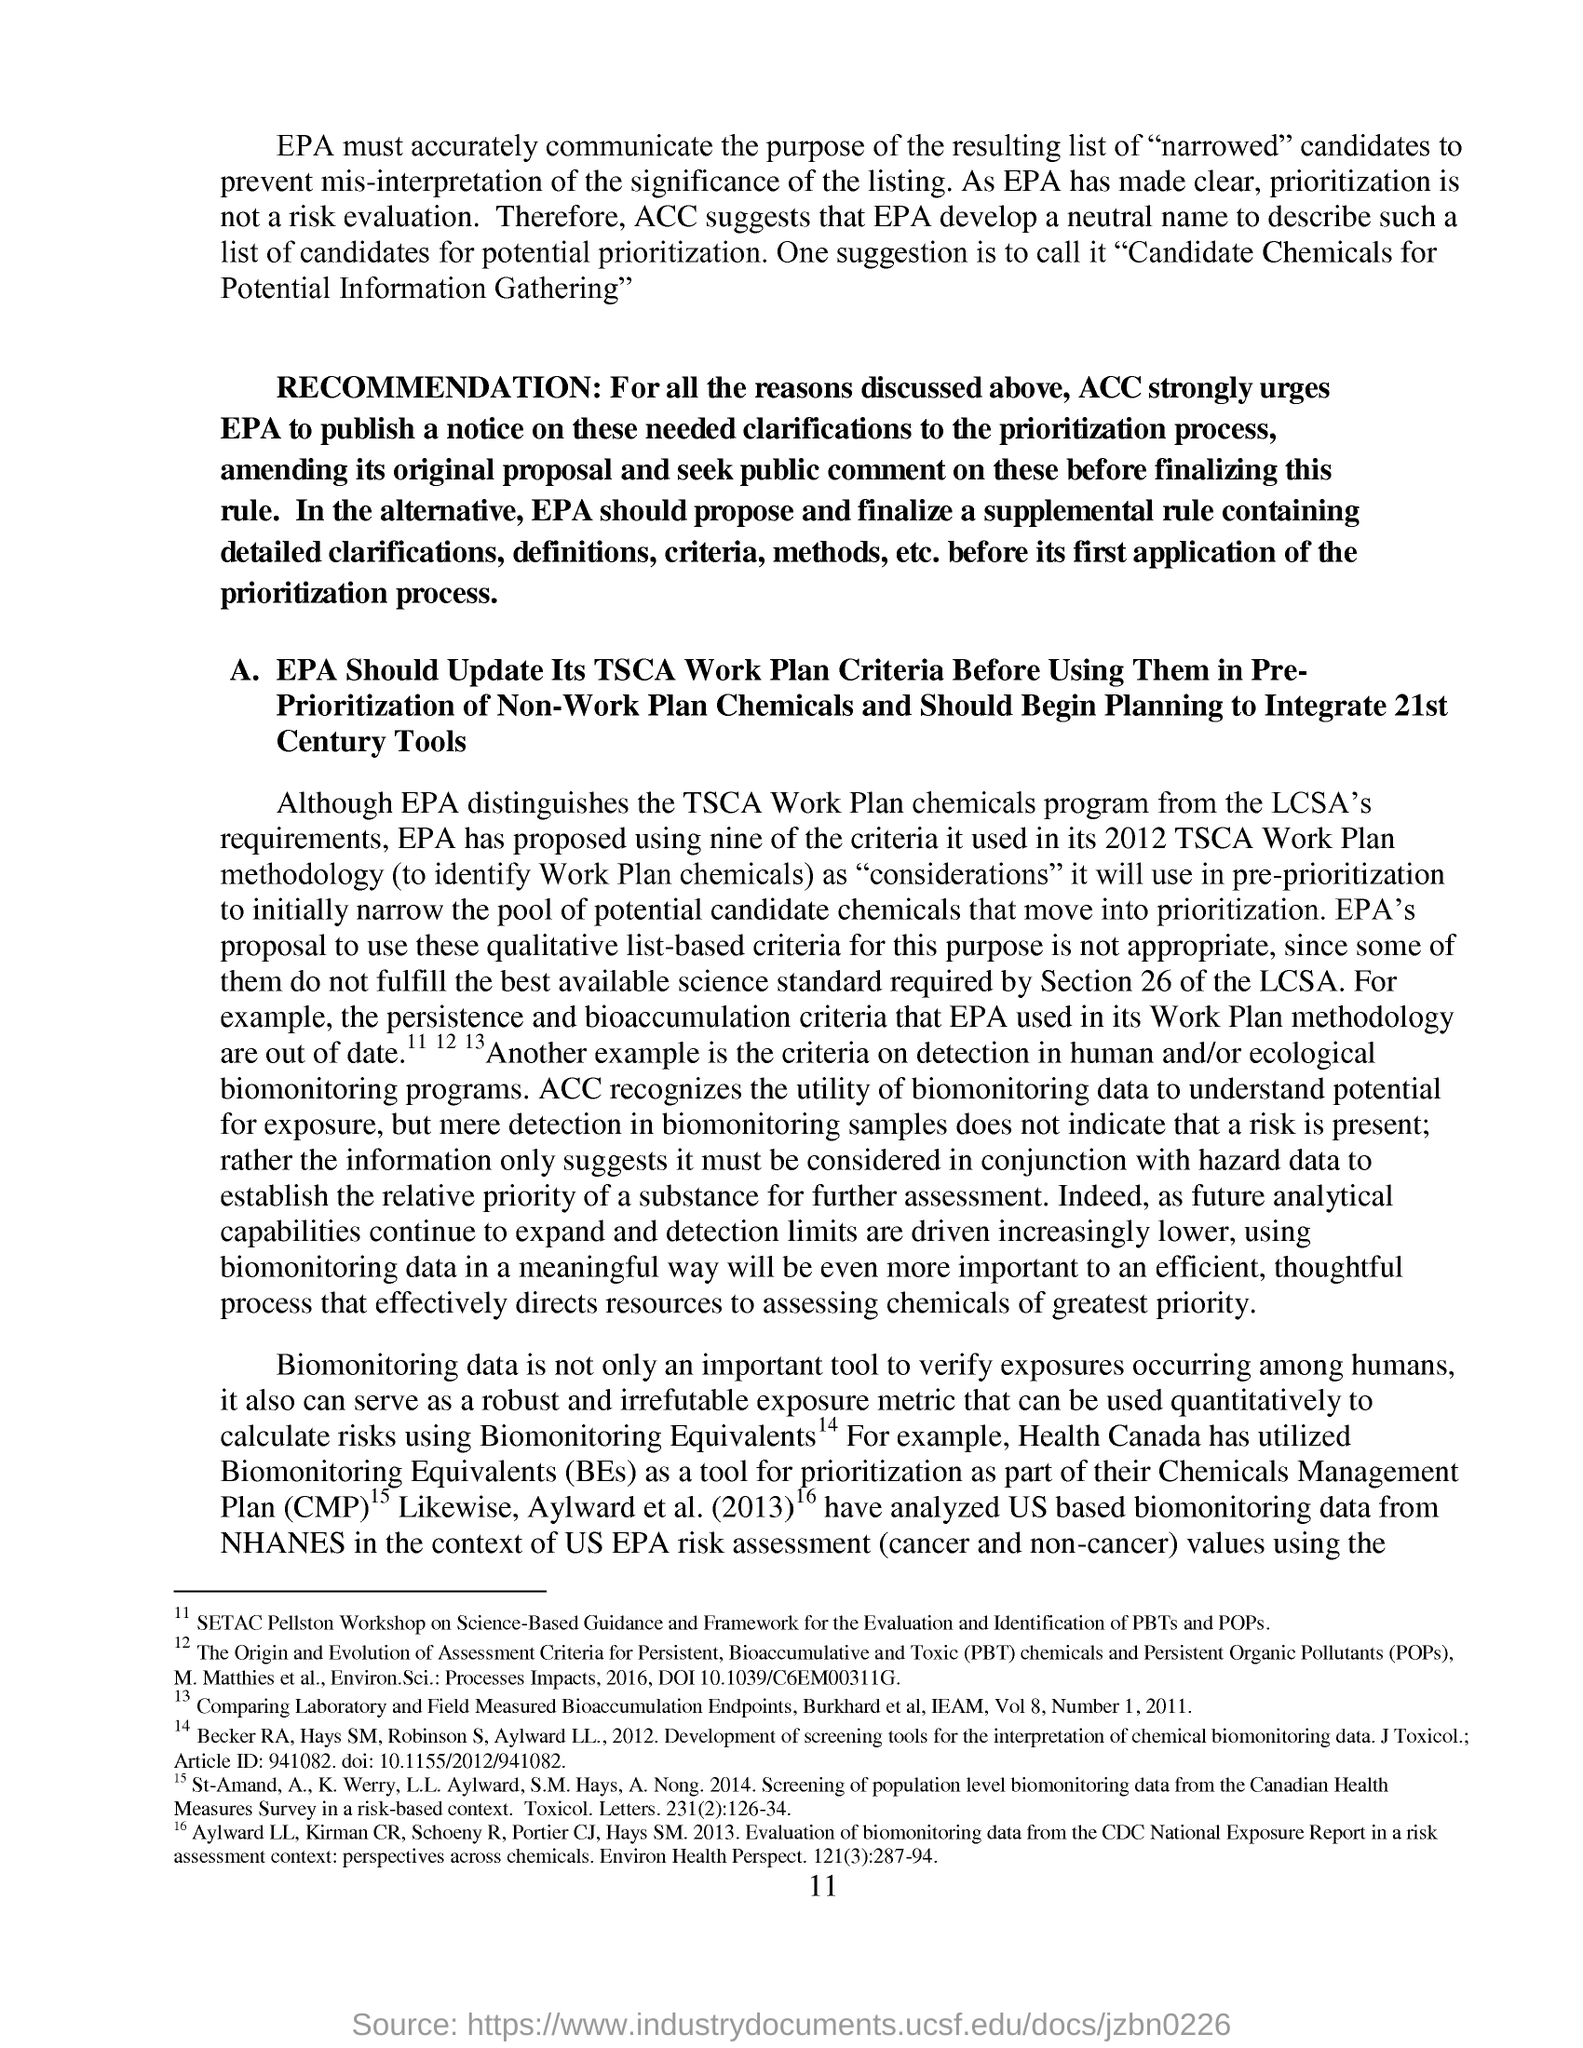List a handful of essential elements in this visual. Chemicals Management Plan, commonly abbreviated as CMP, refers to a comprehensive plan for the safe and responsible management of chemicals in a specific context or industry. The page number mentioned in this document is 11. Biological monitoring equivalents, abbreviated as BEs, are a measure of the potential toxicity of a chemical or other substance to living organisms. 